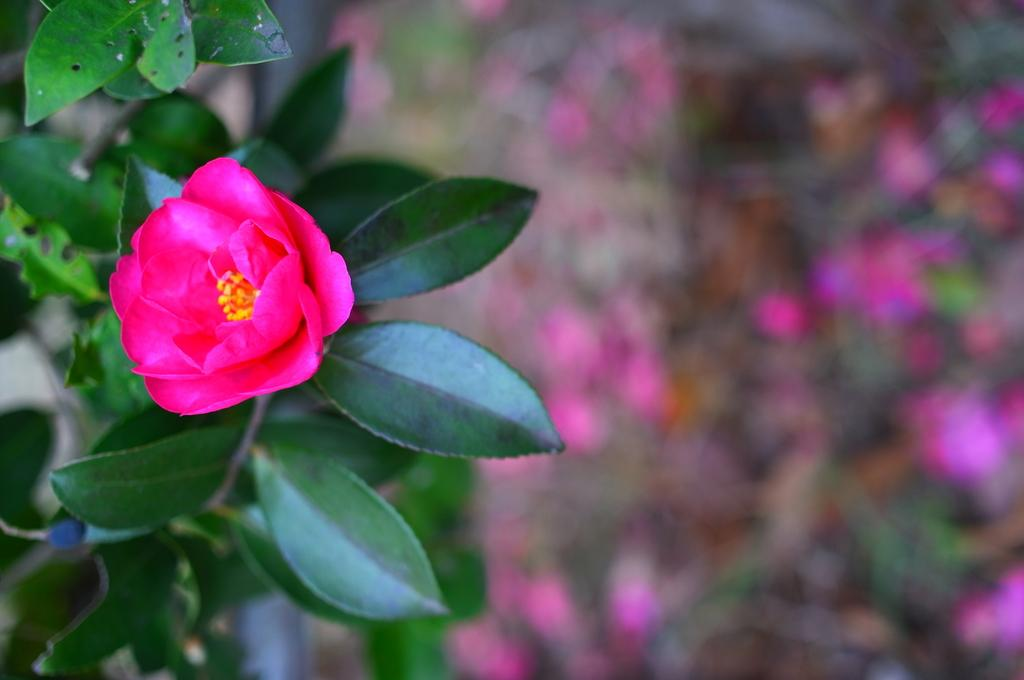What is present in the image? There is a plant in the image. What can be observed about the plant? The plant has a flower. How would you describe the background of the image? The background of the image is blurry. How many kittens are playing with the light bulb in the image? There are no kittens or light bulbs present in the image; it features a plant with a flower and a blurry background. 